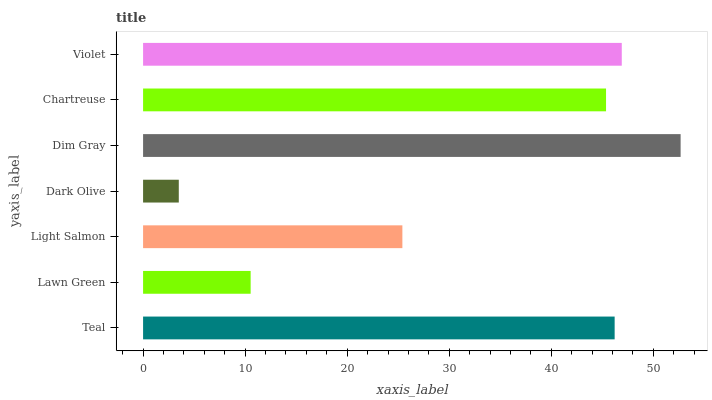Is Dark Olive the minimum?
Answer yes or no. Yes. Is Dim Gray the maximum?
Answer yes or no. Yes. Is Lawn Green the minimum?
Answer yes or no. No. Is Lawn Green the maximum?
Answer yes or no. No. Is Teal greater than Lawn Green?
Answer yes or no. Yes. Is Lawn Green less than Teal?
Answer yes or no. Yes. Is Lawn Green greater than Teal?
Answer yes or no. No. Is Teal less than Lawn Green?
Answer yes or no. No. Is Chartreuse the high median?
Answer yes or no. Yes. Is Chartreuse the low median?
Answer yes or no. Yes. Is Lawn Green the high median?
Answer yes or no. No. Is Dark Olive the low median?
Answer yes or no. No. 